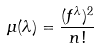<formula> <loc_0><loc_0><loc_500><loc_500>\mu ( \lambda ) = \frac { ( f ^ { \lambda } ) ^ { 2 } } { n ! }</formula> 